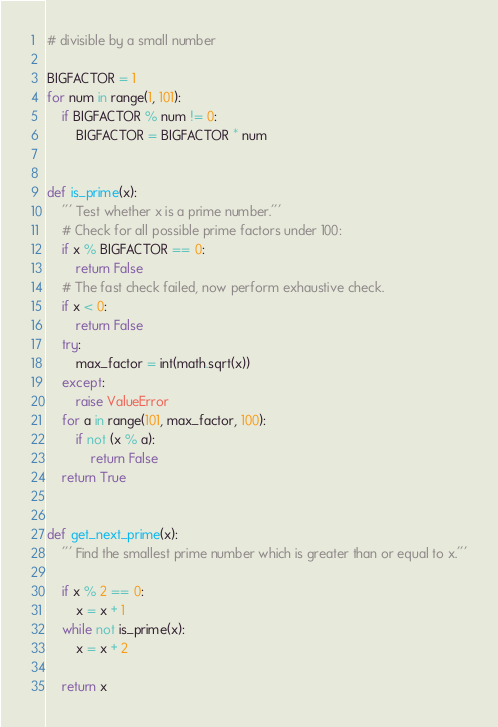<code> <loc_0><loc_0><loc_500><loc_500><_Python_># divisible by a small number

BIGFACTOR = 1
for num in range(1, 101):
    if BIGFACTOR % num != 0:
        BIGFACTOR = BIGFACTOR * num


def is_prime(x):
    ''' Test whether x is a prime number.'''
    # Check for all possible prime factors under 100:
    if x % BIGFACTOR == 0:
        return False
    # The fast check failed, now perform exhaustive check.
    if x < 0:
        return False
    try:
        max_factor = int(math.sqrt(x))
    except:
        raise ValueError
    for a in range(101, max_factor, 100):
        if not (x % a):
            return False
    return True


def get_next_prime(x):
    ''' Find the smallest prime number which is greater than or equal to x.'''

    if x % 2 == 0:
        x = x + 1
    while not is_prime(x):
        x = x + 2

    return x
</code> 